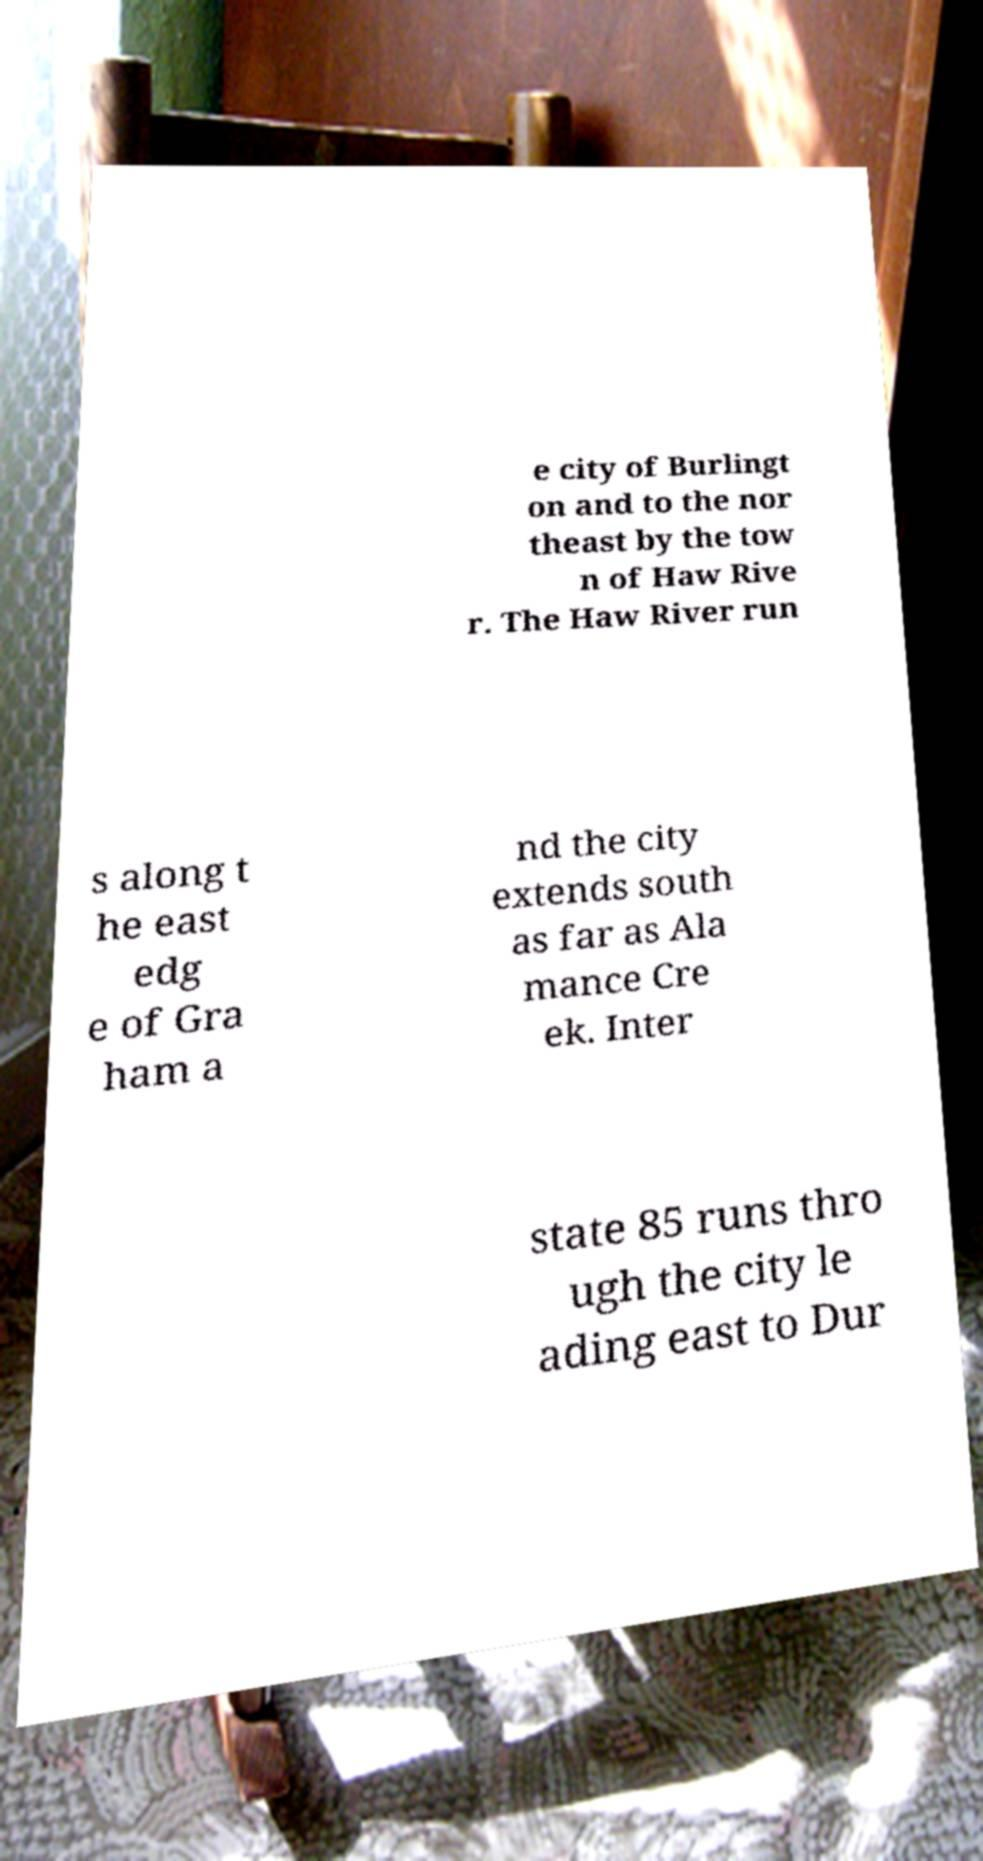Please read and relay the text visible in this image. What does it say? e city of Burlingt on and to the nor theast by the tow n of Haw Rive r. The Haw River run s along t he east edg e of Gra ham a nd the city extends south as far as Ala mance Cre ek. Inter state 85 runs thro ugh the city le ading east to Dur 